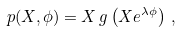Convert formula to latex. <formula><loc_0><loc_0><loc_500><loc_500>p ( X , \phi ) = X \, g \left ( X e ^ { \lambda \phi } \right ) \, ,</formula> 